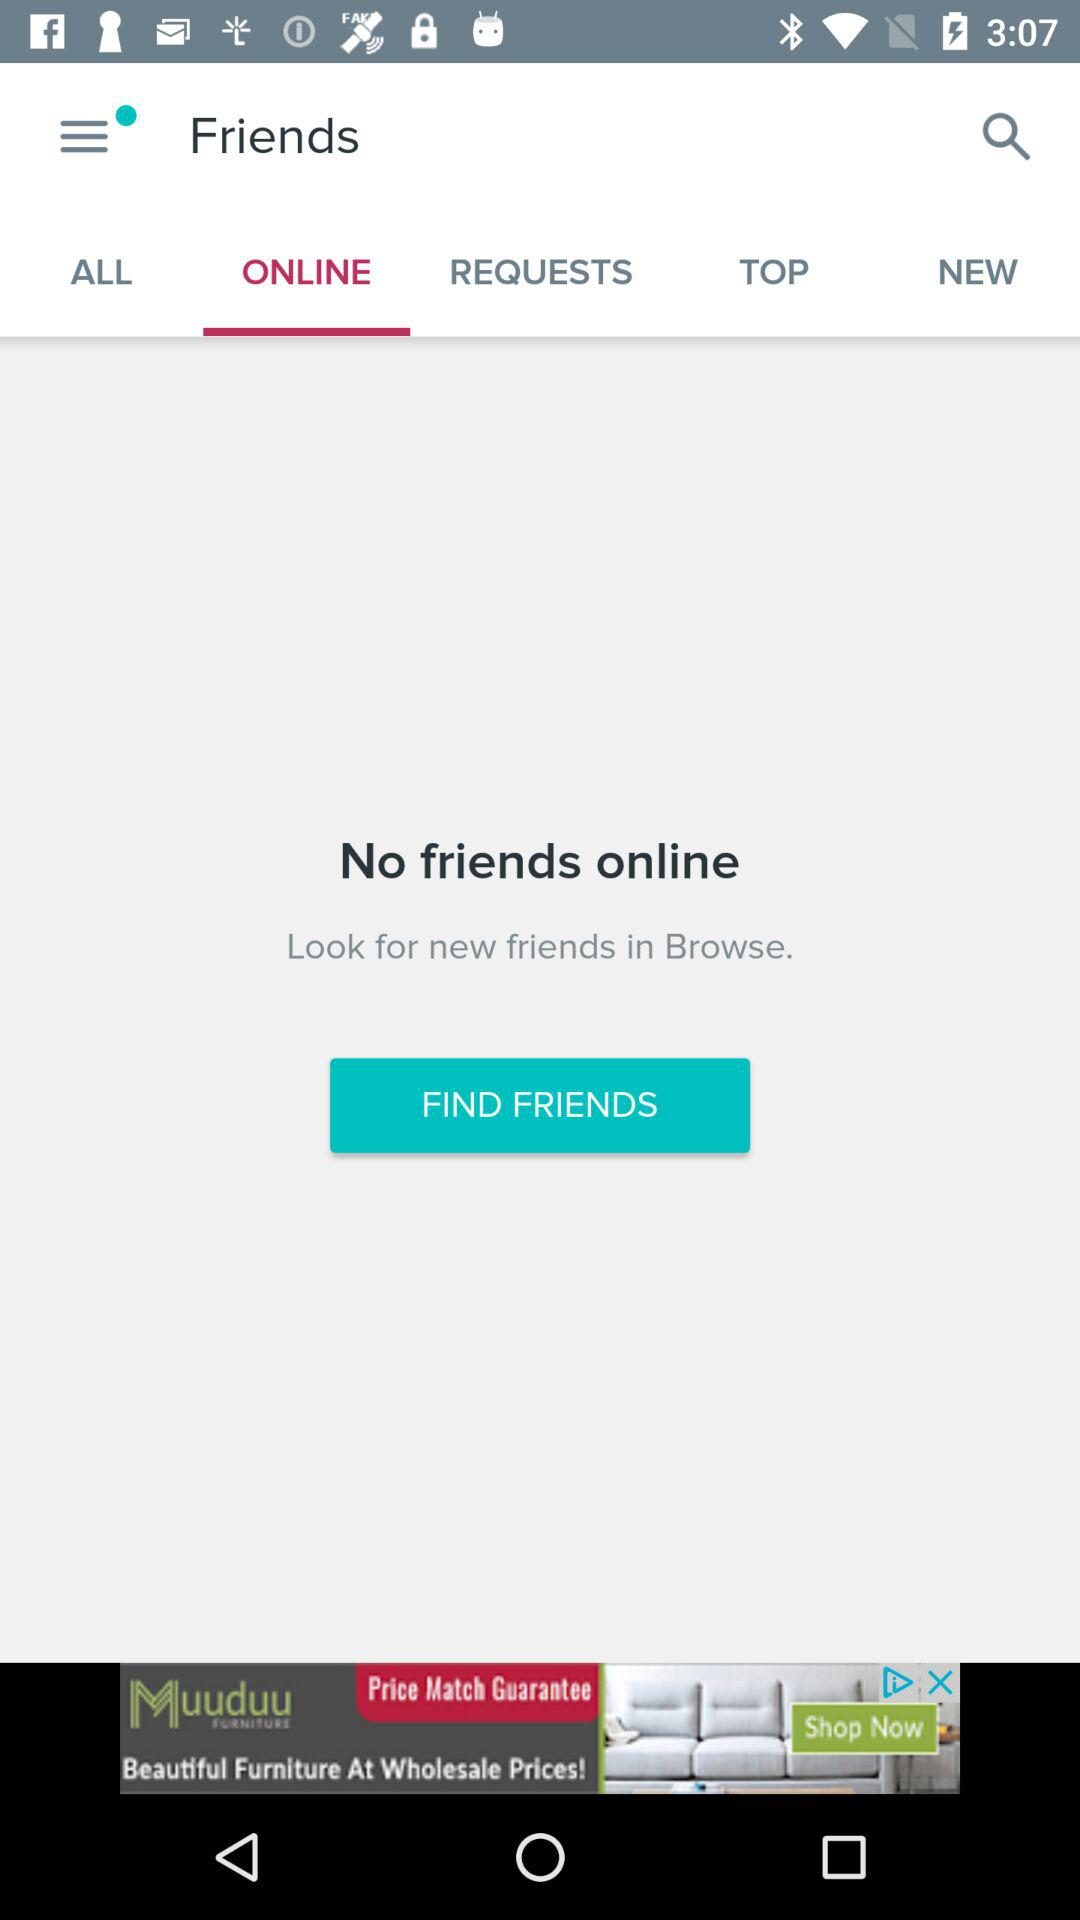Which tab is selected? The selected tab is "ONLINE". 